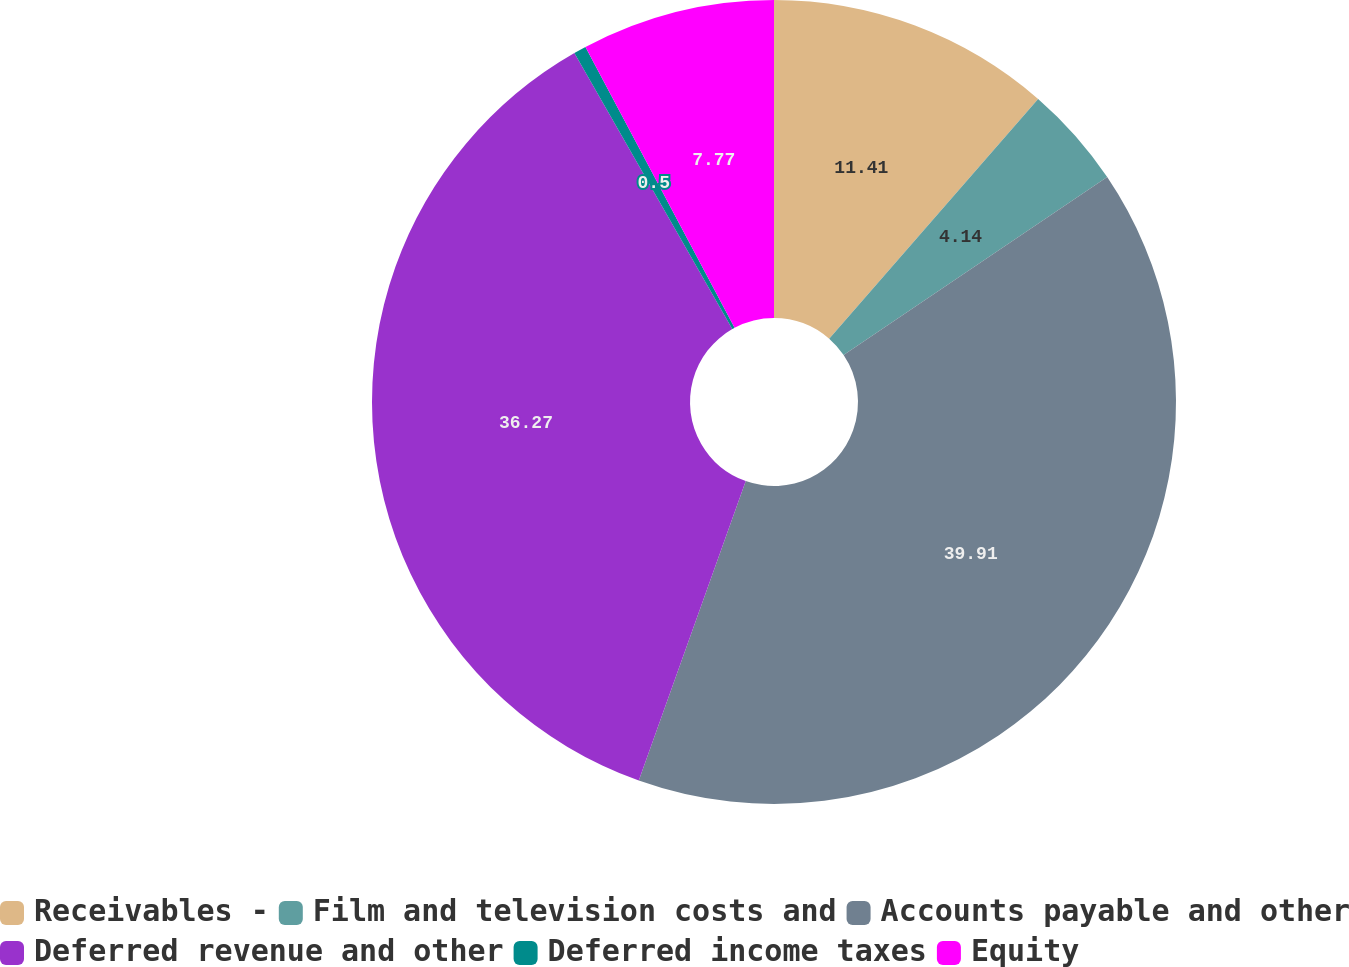Convert chart. <chart><loc_0><loc_0><loc_500><loc_500><pie_chart><fcel>Receivables -<fcel>Film and television costs and<fcel>Accounts payable and other<fcel>Deferred revenue and other<fcel>Deferred income taxes<fcel>Equity<nl><fcel>11.41%<fcel>4.14%<fcel>39.91%<fcel>36.27%<fcel>0.5%<fcel>7.77%<nl></chart> 